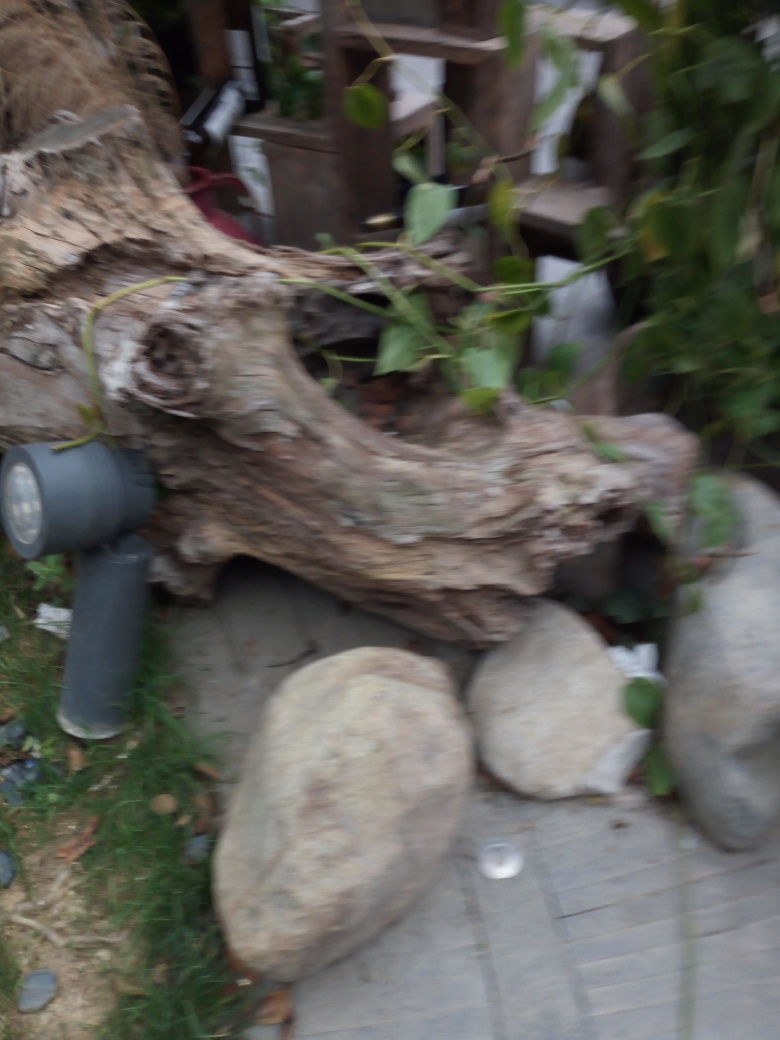How does the image appear?
A. Clear
B. Sharp
C. Blurry
D. Fuzzy
Answer with the option's letter from the given choices directly.
 C. 